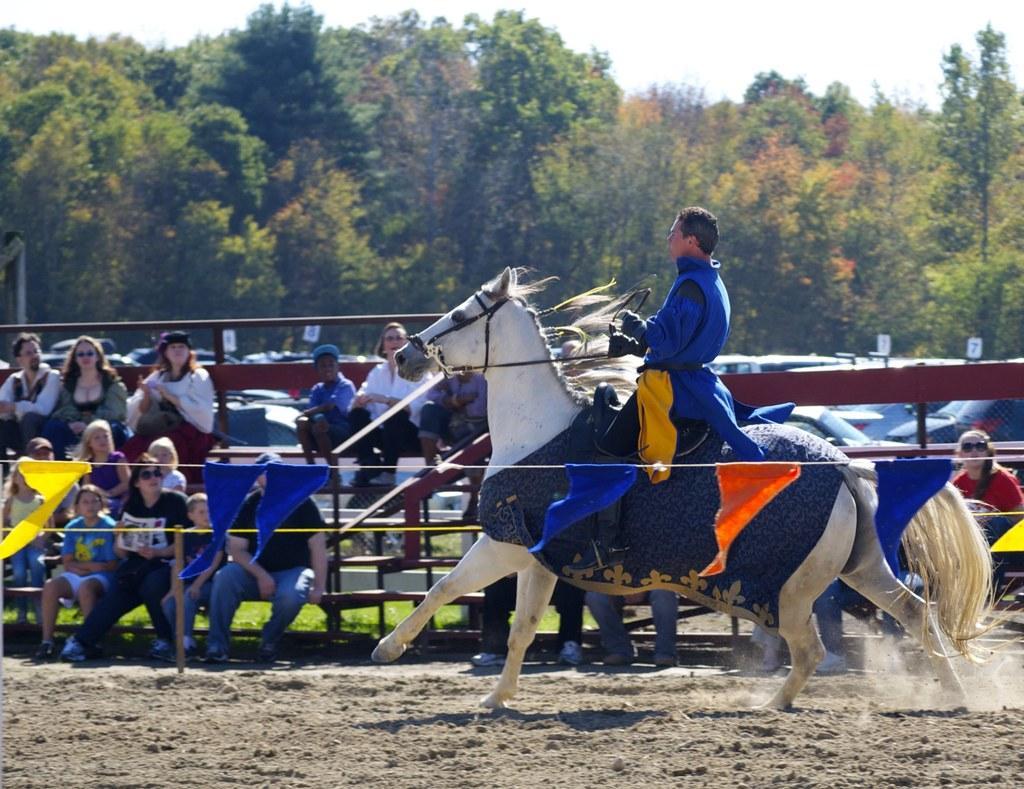How would you summarize this image in a sentence or two? In the foreground of this image, there are bunting flags and a man riding horse on the sand. In the background, there is a railing, persons sitting, vehicles parked, trees and the sky. 